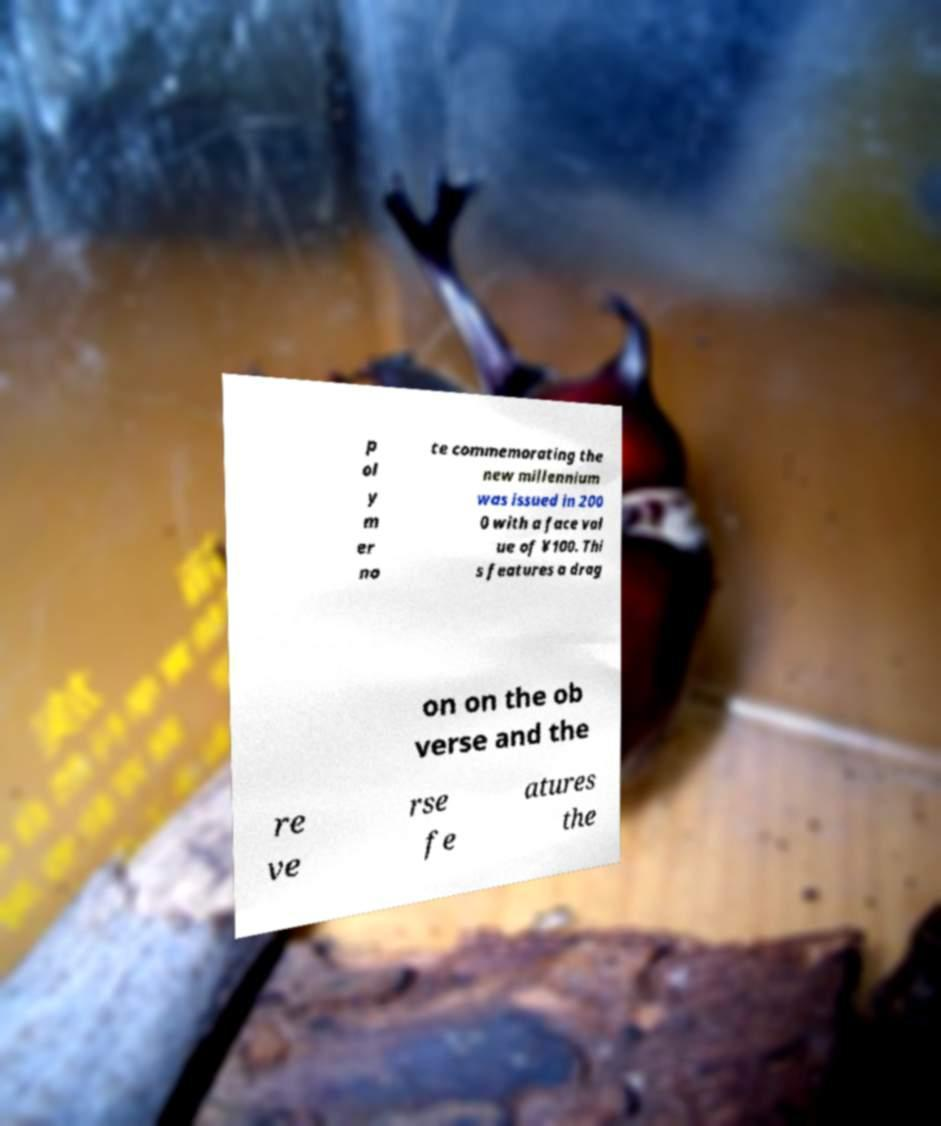Please identify and transcribe the text found in this image. p ol y m er no te commemorating the new millennium was issued in 200 0 with a face val ue of ¥100. Thi s features a drag on on the ob verse and the re ve rse fe atures the 